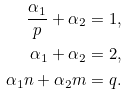Convert formula to latex. <formula><loc_0><loc_0><loc_500><loc_500>\frac { \alpha _ { 1 } } p + \alpha _ { 2 } & = 1 , \\ \alpha _ { 1 } + \alpha _ { 2 } & = 2 , \\ \alpha _ { 1 } n + \alpha _ { 2 } m & = q .</formula> 